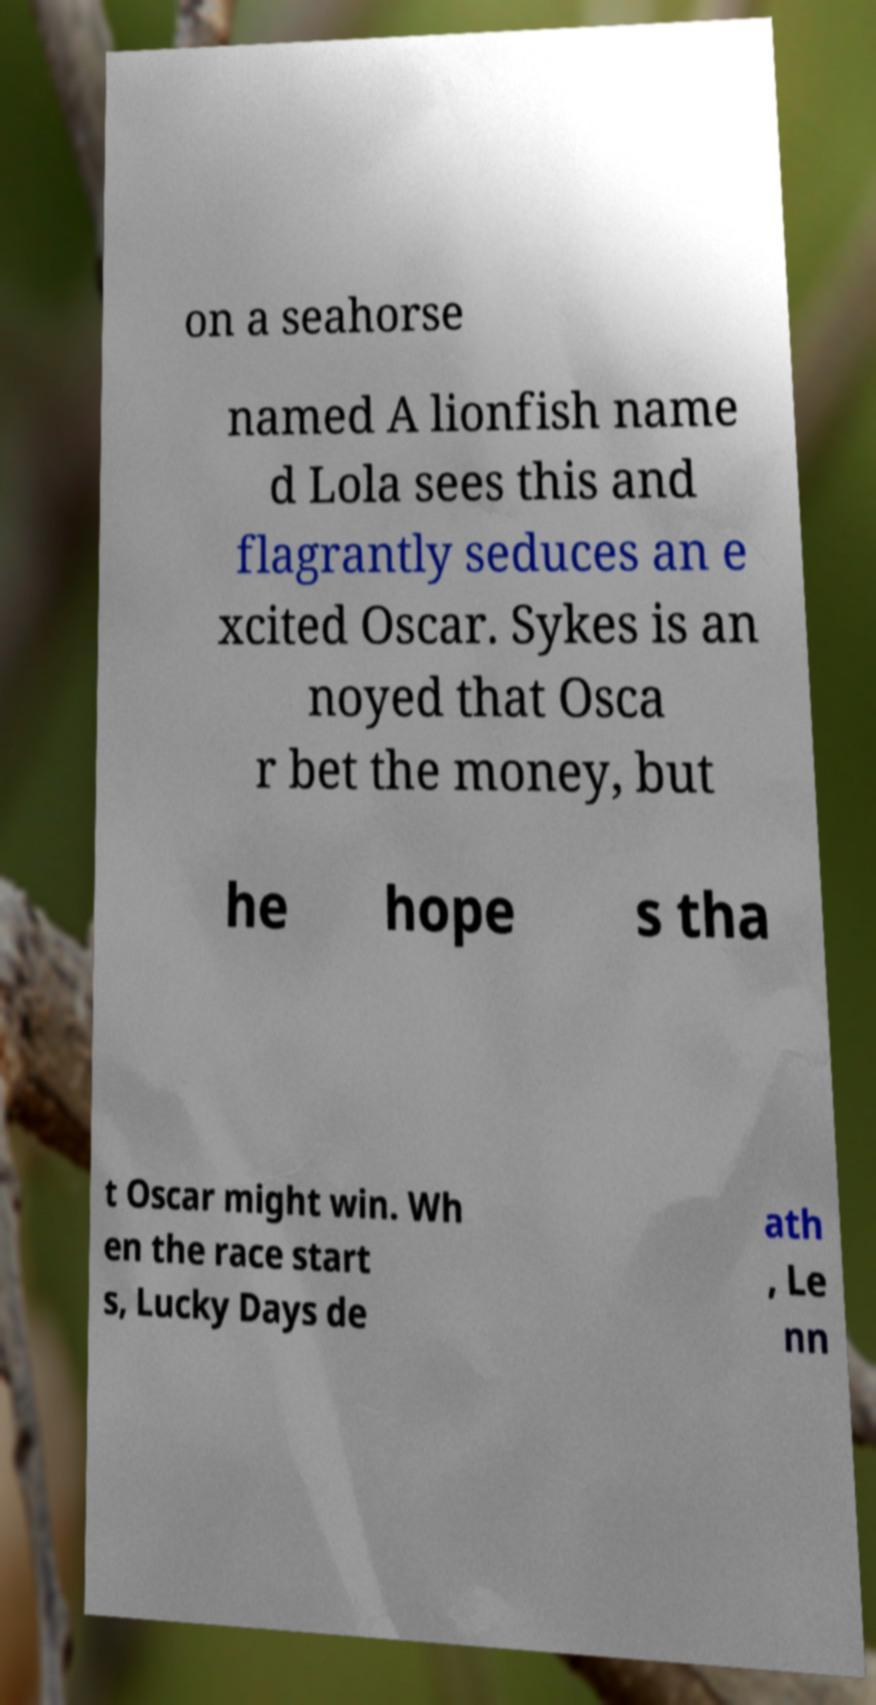Can you read and provide the text displayed in the image?This photo seems to have some interesting text. Can you extract and type it out for me? on a seahorse named A lionfish name d Lola sees this and flagrantly seduces an e xcited Oscar. Sykes is an noyed that Osca r bet the money, but he hope s tha t Oscar might win. Wh en the race start s, Lucky Days de ath , Le nn 